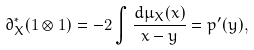<formula> <loc_0><loc_0><loc_500><loc_500>\partial _ { X } ^ { * } ( 1 \otimes 1 ) = - 2 \int \frac { d \mu _ { X } ( x ) } { x - y } = p ^ { \prime } ( y ) ,</formula> 